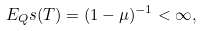<formula> <loc_0><loc_0><loc_500><loc_500>E _ { Q } s ( T ) = ( 1 - \mu ) ^ { - 1 } < \infty ,</formula> 